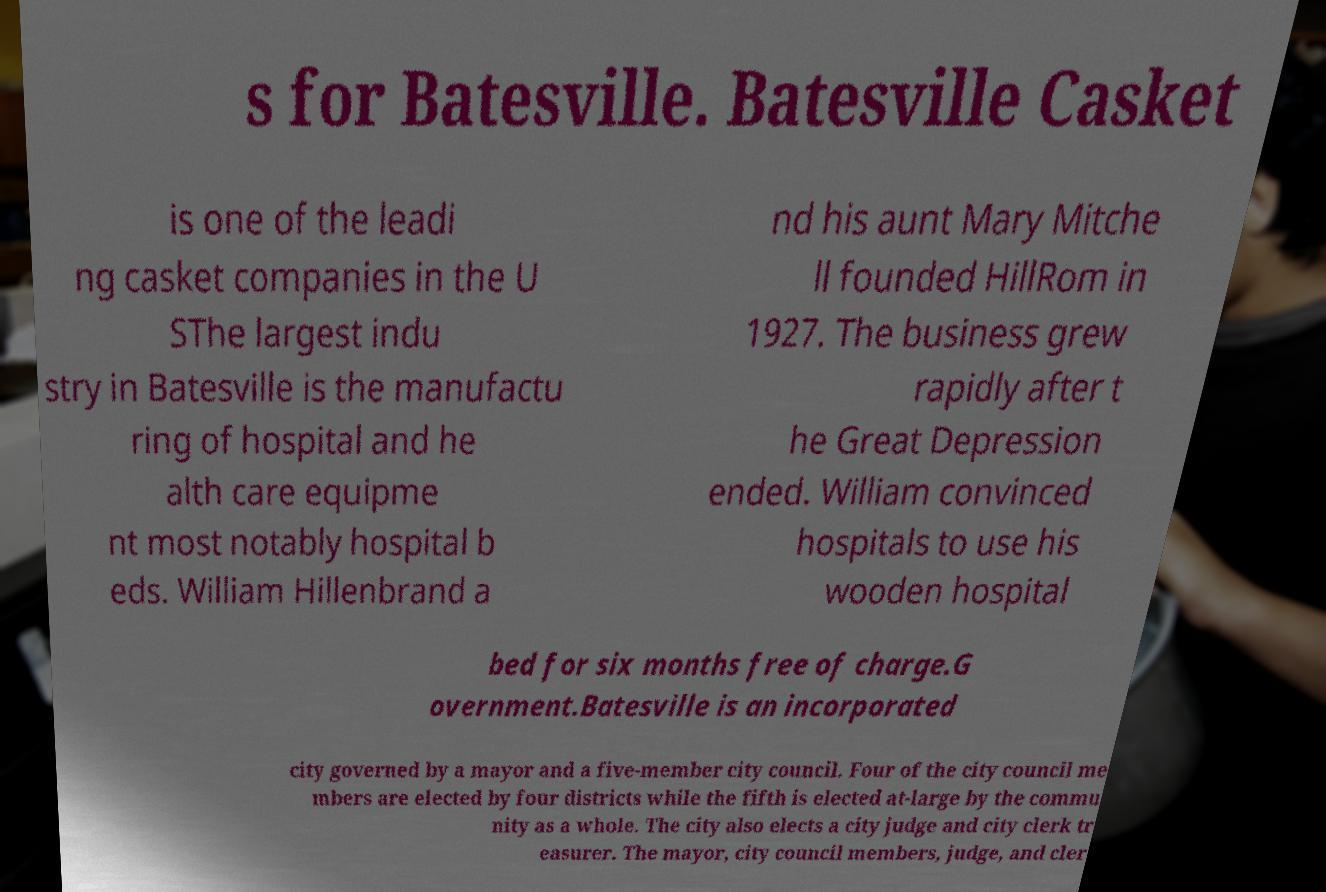Could you assist in decoding the text presented in this image and type it out clearly? s for Batesville. Batesville Casket is one of the leadi ng casket companies in the U SThe largest indu stry in Batesville is the manufactu ring of hospital and he alth care equipme nt most notably hospital b eds. William Hillenbrand a nd his aunt Mary Mitche ll founded HillRom in 1927. The business grew rapidly after t he Great Depression ended. William convinced hospitals to use his wooden hospital bed for six months free of charge.G overnment.Batesville is an incorporated city governed by a mayor and a five-member city council. Four of the city council me mbers are elected by four districts while the fifth is elected at-large by the commu nity as a whole. The city also elects a city judge and city clerk tr easurer. The mayor, city council members, judge, and cler 